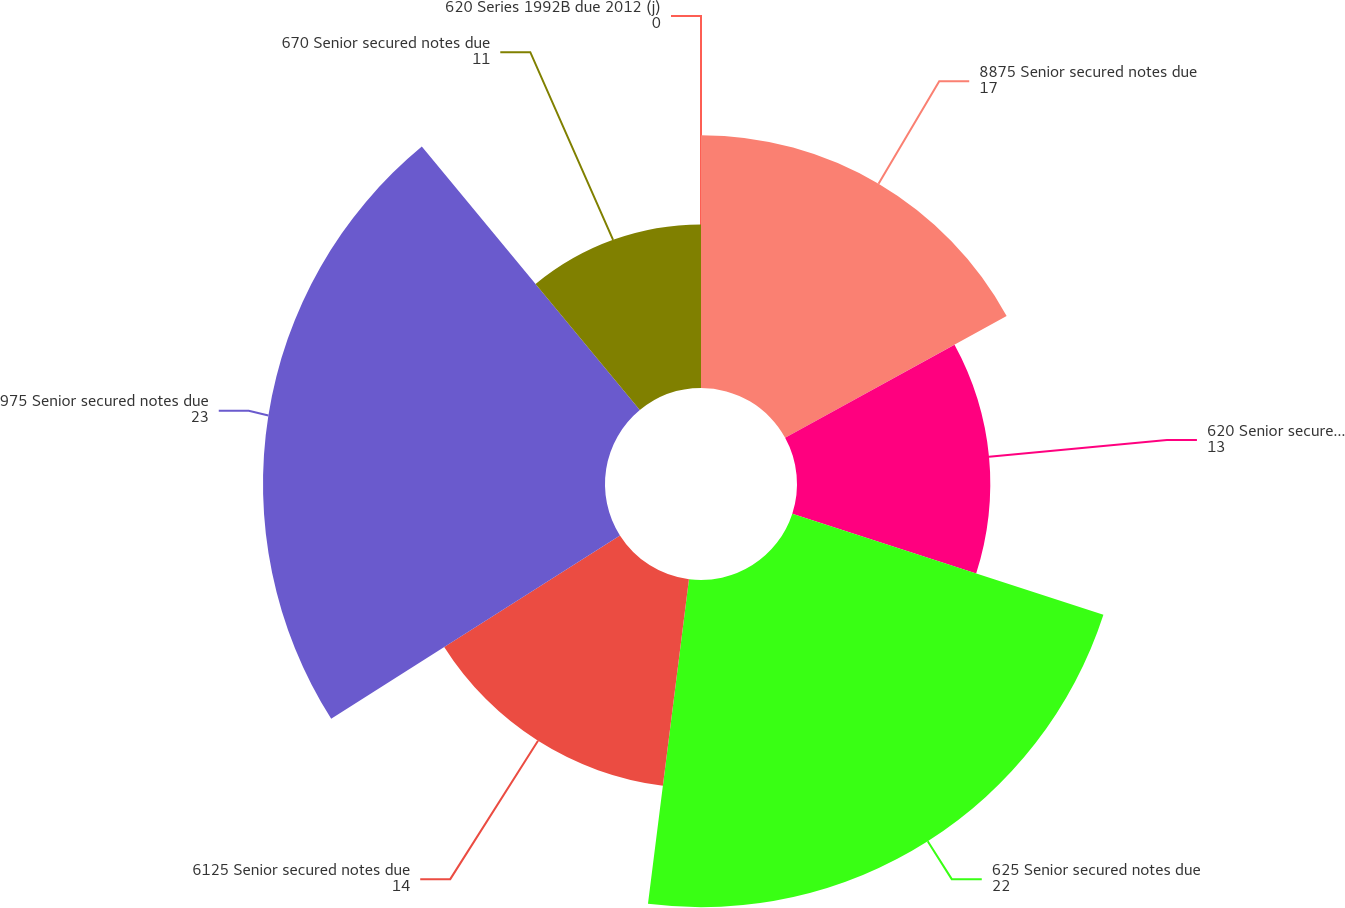<chart> <loc_0><loc_0><loc_500><loc_500><pie_chart><fcel>8875 Senior secured notes due<fcel>620 Senior secured notes due<fcel>625 Senior secured notes due<fcel>6125 Senior secured notes due<fcel>975 Senior secured notes due<fcel>670 Senior secured notes due<fcel>620 Series 1992B due 2012 (j)<nl><fcel>17.0%<fcel>13.0%<fcel>22.0%<fcel>14.0%<fcel>23.0%<fcel>11.0%<fcel>0.0%<nl></chart> 